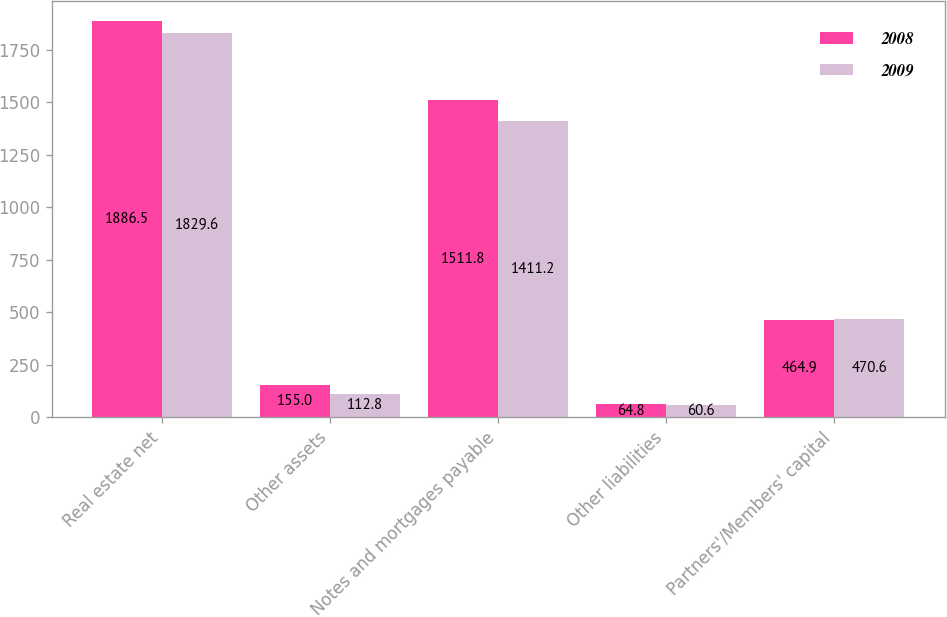<chart> <loc_0><loc_0><loc_500><loc_500><stacked_bar_chart><ecel><fcel>Real estate net<fcel>Other assets<fcel>Notes and mortgages payable<fcel>Other liabilities<fcel>Partners'/Members' capital<nl><fcel>2008<fcel>1886.5<fcel>155<fcel>1511.8<fcel>64.8<fcel>464.9<nl><fcel>2009<fcel>1829.6<fcel>112.8<fcel>1411.2<fcel>60.6<fcel>470.6<nl></chart> 